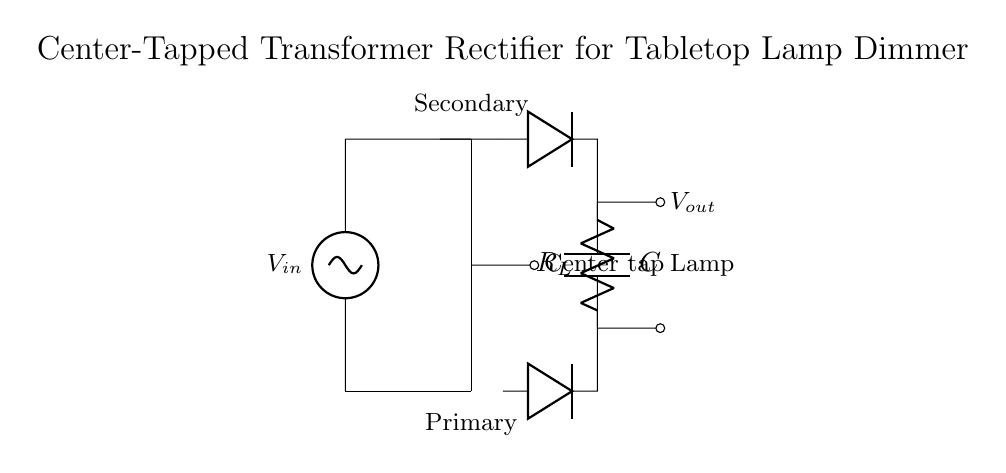What type of transformer is used in this circuit? The diagram shows a center-tapped transformer, indicated by the center tap notation and the two diodes positioned to utilize both sides of the secondary winding.
Answer: Center-tapped What is the function of the diodes in this circuit? The diodes create a full-wave rectification by allowing current to pass in both directions while blocking reverse current, converting AC to DC.
Answer: Rectification What component is represented by 'C' in the circuit? 'C' designates a capacitor, which is used to smooth the output voltage by filtering fluctuations after rectification.
Answer: Capacitor What is the purpose of the center tap in this transformer? The center tap provides two equal voltages from the transformer, allowing for full-wave rectification, effectively utilizing both halves of the AC waveform.
Answer: Full-wave rectification What does 'R_L' represent in this circuit? 'R_L' is the load resistor, which represents the resistance connected to the output to consume power from the rectified output voltage.
Answer: Load resistor What will happen if the capacitor 'C' were to be removed? Without the capacitor, the output voltage would be rippled and less stable, leading to fluctuations without any filtering, which could affect the lamp's brightness.
Answer: Rippled output How many diodes are used in this rectifier circuit? There are two diodes in this circuit configured to handle both halves of the AC signal through the center tap of the transformer.
Answer: Two 